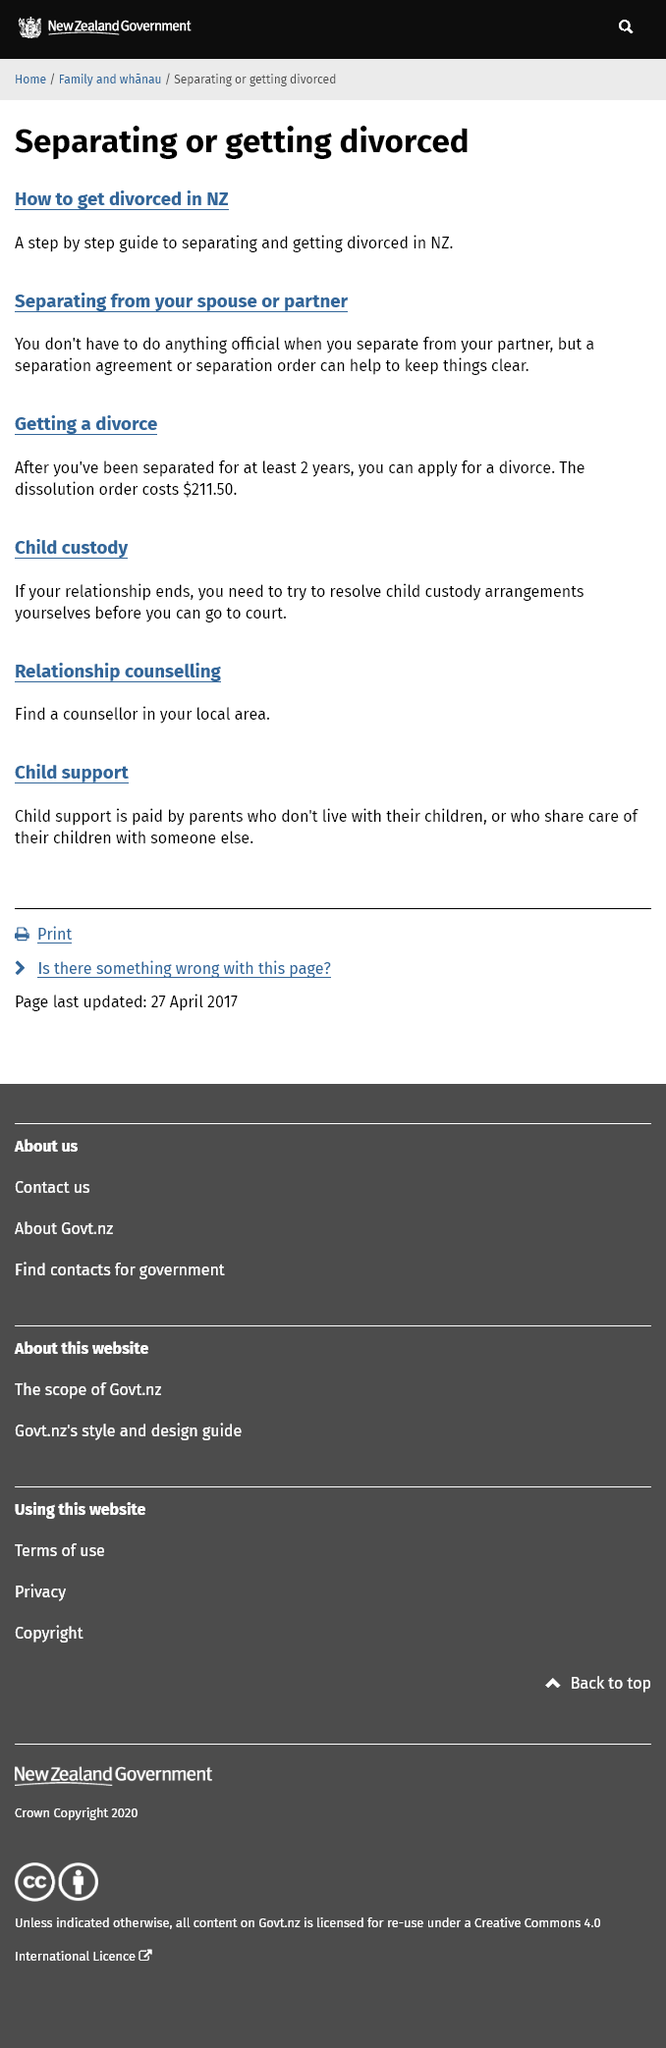Draw attention to some important aspects in this diagram. The dissolution order in New Zealand costs $211.50. In order to attend court in New Zealand, it is necessary to try to resolve any outstanding child custody arrangements. In New Zealand, a couple must be separated for at least two years before they can apply for a divorce. 